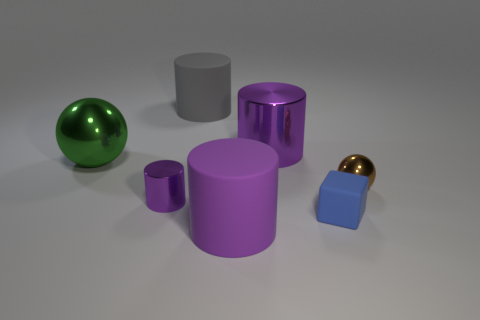How many purple cylinders must be subtracted to get 1 purple cylinders? 2 Subtract all brown blocks. How many purple cylinders are left? 3 Subtract all cyan cylinders. Subtract all purple spheres. How many cylinders are left? 4 Add 3 tiny green metallic cubes. How many objects exist? 10 Subtract all balls. How many objects are left? 5 Add 2 spheres. How many spheres are left? 4 Add 5 large purple rubber things. How many large purple rubber things exist? 6 Subtract 0 gray balls. How many objects are left? 7 Subtract all rubber objects. Subtract all large yellow metal things. How many objects are left? 4 